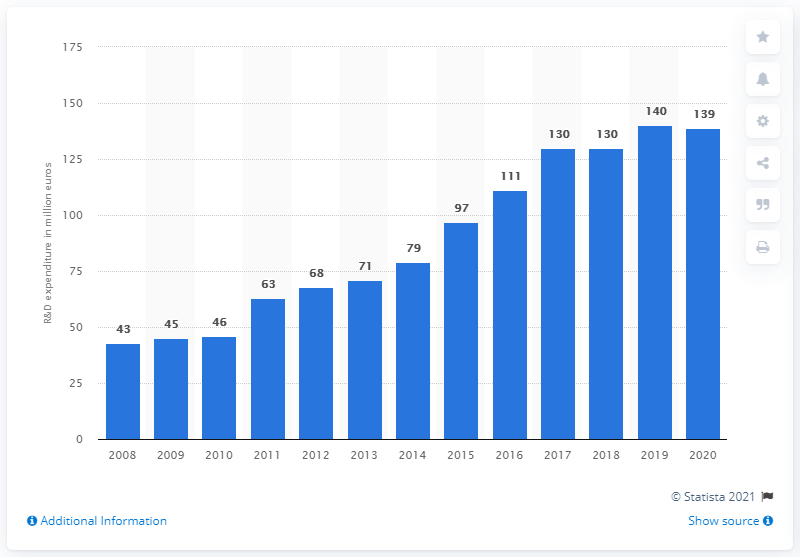Mention a couple of crucial points in this snapshot. LVMH Group's global research and development expenditure in 2019 was 139 million. 